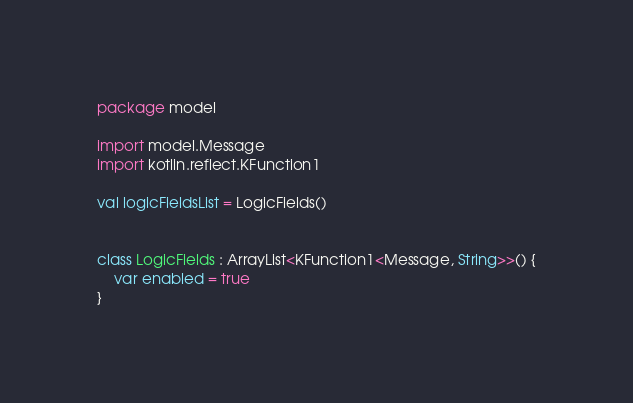Convert code to text. <code><loc_0><loc_0><loc_500><loc_500><_Kotlin_>package model

import model.Message
import kotlin.reflect.KFunction1

val logicFieldsList = LogicFields()


class LogicFields : ArrayList<KFunction1<Message, String>>() {
    var enabled = true
}
</code> 